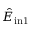<formula> <loc_0><loc_0><loc_500><loc_500>\hat { E } _ { i n 1 }</formula> 